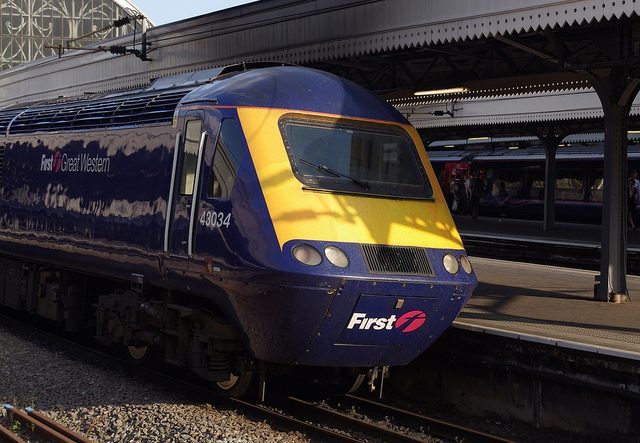<image>What is the brand of train? I don't know the brand of the train, but it could be 'first' or 'first great western'. What is the brand of train? I don't know the brand of the train. It can be "first", "passenger" or "first great western". 